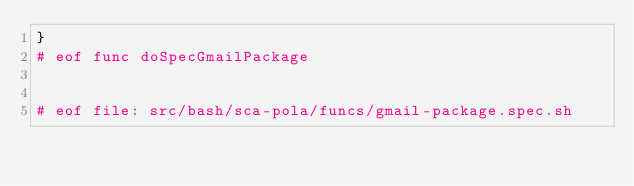<code> <loc_0><loc_0><loc_500><loc_500><_Bash_>}
# eof func doSpecGmailPackage


# eof file: src/bash/sca-pola/funcs/gmail-package.spec.sh
</code> 